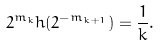Convert formula to latex. <formula><loc_0><loc_0><loc_500><loc_500>2 ^ { m _ { k } } h ( 2 ^ { - m _ { k + 1 } } ) = \frac { 1 } { k } .</formula> 